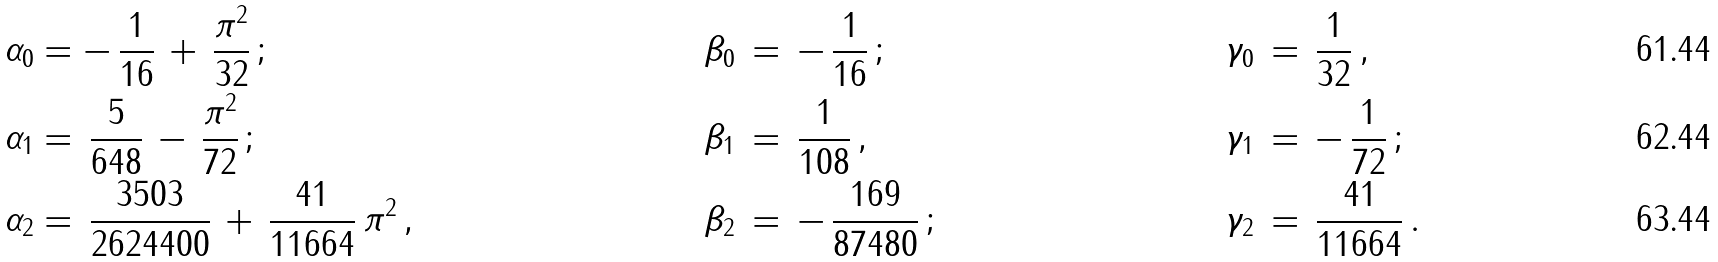Convert formula to latex. <formula><loc_0><loc_0><loc_500><loc_500>\alpha _ { 0 } & = - \, \frac { 1 } { 1 6 } \, + \, \frac { \pi ^ { 2 } } { 3 2 } \, ; & \beta _ { 0 } \, & = \, - \, \frac { 1 } { 1 6 } \, ; & \gamma _ { 0 } \, & = \, \frac { 1 } { 3 2 } \, , \\ \alpha _ { 1 } & = \, \frac { 5 } { 6 4 8 } \, - \, \frac { \pi ^ { 2 } } { 7 2 } \, ; & \beta _ { 1 } \, & = \, \frac { 1 } { 1 0 8 } \, , & \gamma _ { 1 } \, & = \, - \, \frac { 1 } { 7 2 } \, ; \\ \alpha _ { 2 } & = \, \frac { 3 5 0 3 } { 2 6 2 4 4 0 0 } \, + \, \frac { 4 1 } { 1 1 6 6 4 } \, \pi ^ { 2 } \, , & \beta _ { 2 } \, & = \, - \, \frac { 1 6 9 } { 8 7 4 8 0 } \, ; & \gamma _ { 2 } \, & = \, \frac { 4 1 } { 1 1 6 6 4 } \, .</formula> 